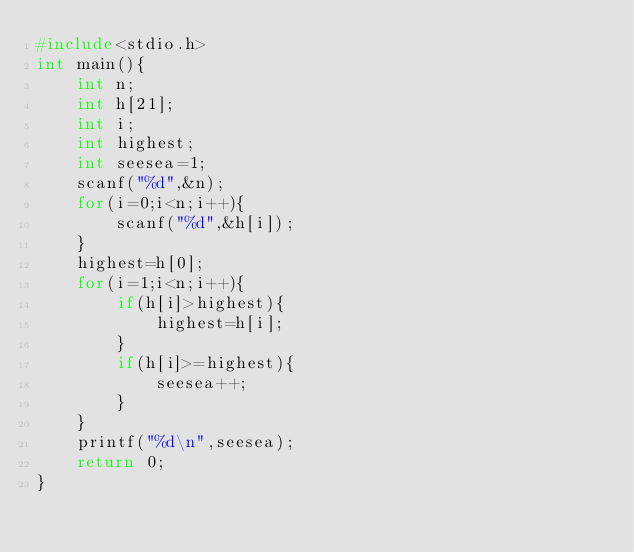<code> <loc_0><loc_0><loc_500><loc_500><_C_>#include<stdio.h>
int main(){
    int n;
    int h[21];
    int i;
    int highest;
    int seesea=1;
    scanf("%d",&n);
    for(i=0;i<n;i++){
        scanf("%d",&h[i]);
    }
    highest=h[0];
    for(i=1;i<n;i++){
        if(h[i]>highest){
            highest=h[i];
        }
        if(h[i]>=highest){
            seesea++;
        }
    }
    printf("%d\n",seesea);
    return 0;
}</code> 